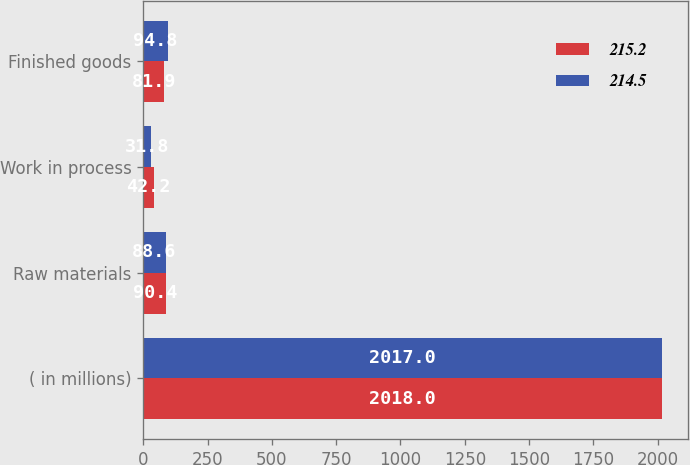Convert chart. <chart><loc_0><loc_0><loc_500><loc_500><stacked_bar_chart><ecel><fcel>( in millions)<fcel>Raw materials<fcel>Work in process<fcel>Finished goods<nl><fcel>215.2<fcel>2018<fcel>90.4<fcel>42.2<fcel>81.9<nl><fcel>214.5<fcel>2017<fcel>88.6<fcel>31.8<fcel>94.8<nl></chart> 